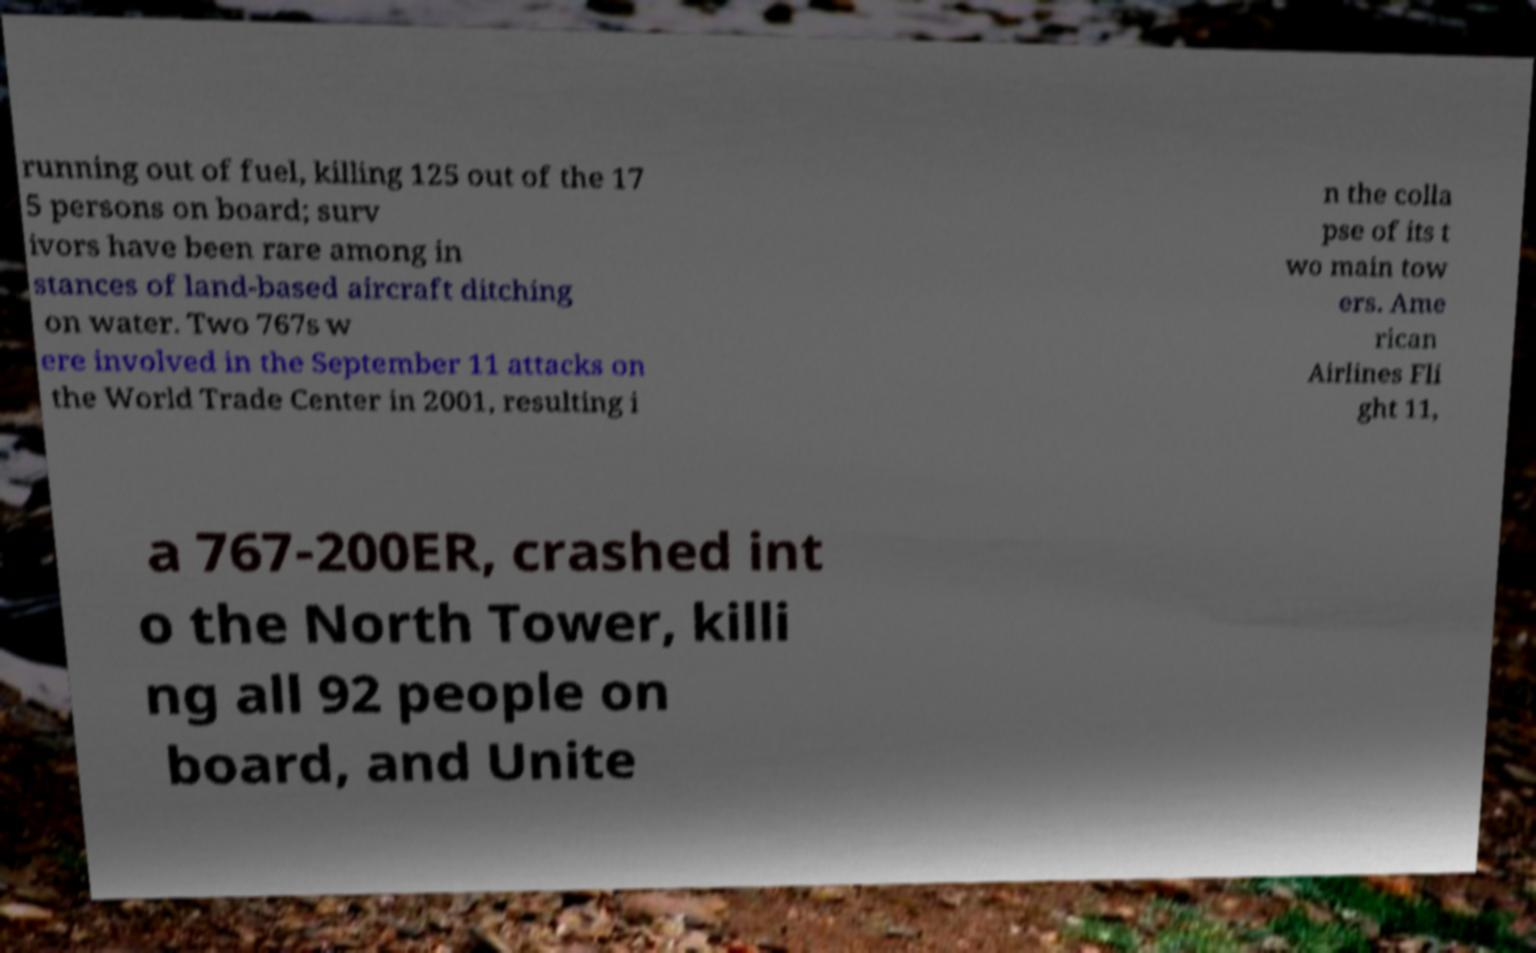Could you extract and type out the text from this image? running out of fuel, killing 125 out of the 17 5 persons on board; surv ivors have been rare among in stances of land-based aircraft ditching on water. Two 767s w ere involved in the September 11 attacks on the World Trade Center in 2001, resulting i n the colla pse of its t wo main tow ers. Ame rican Airlines Fli ght 11, a 767-200ER, crashed int o the North Tower, killi ng all 92 people on board, and Unite 